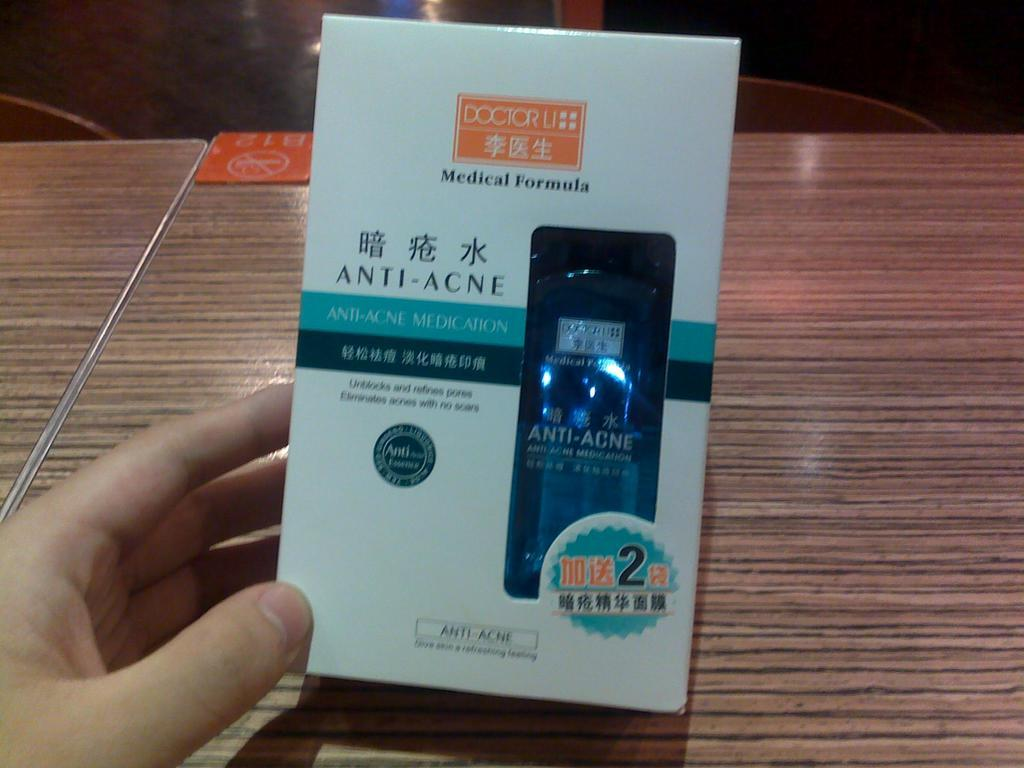<image>
Share a concise interpretation of the image provided. A packaged product that is an anti-acne treatment. 